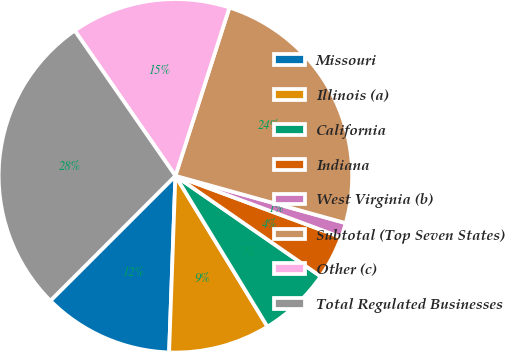Convert chart to OTSL. <chart><loc_0><loc_0><loc_500><loc_500><pie_chart><fcel>Missouri<fcel>Illinois (a)<fcel>California<fcel>Indiana<fcel>West Virginia (b)<fcel>Subtotal (Top Seven States)<fcel>Other (c)<fcel>Total Regulated Businesses<nl><fcel>11.94%<fcel>9.29%<fcel>6.64%<fcel>3.99%<fcel>1.34%<fcel>24.37%<fcel>14.59%<fcel>27.85%<nl></chart> 